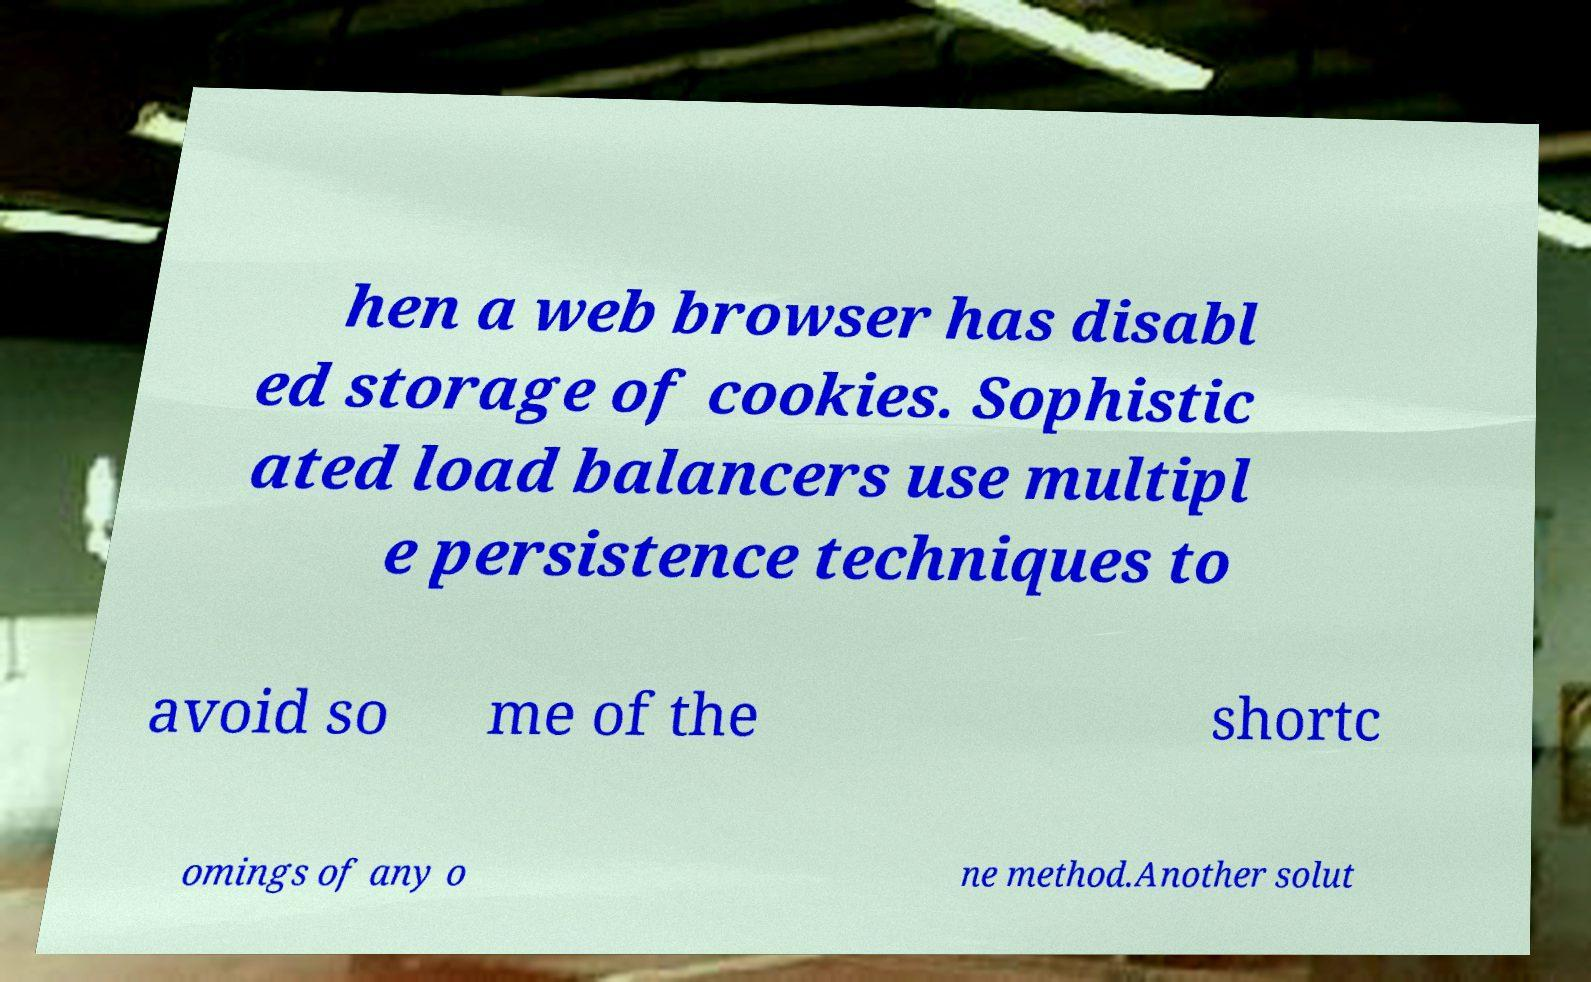There's text embedded in this image that I need extracted. Can you transcribe it verbatim? hen a web browser has disabl ed storage of cookies. Sophistic ated load balancers use multipl e persistence techniques to avoid so me of the shortc omings of any o ne method.Another solut 